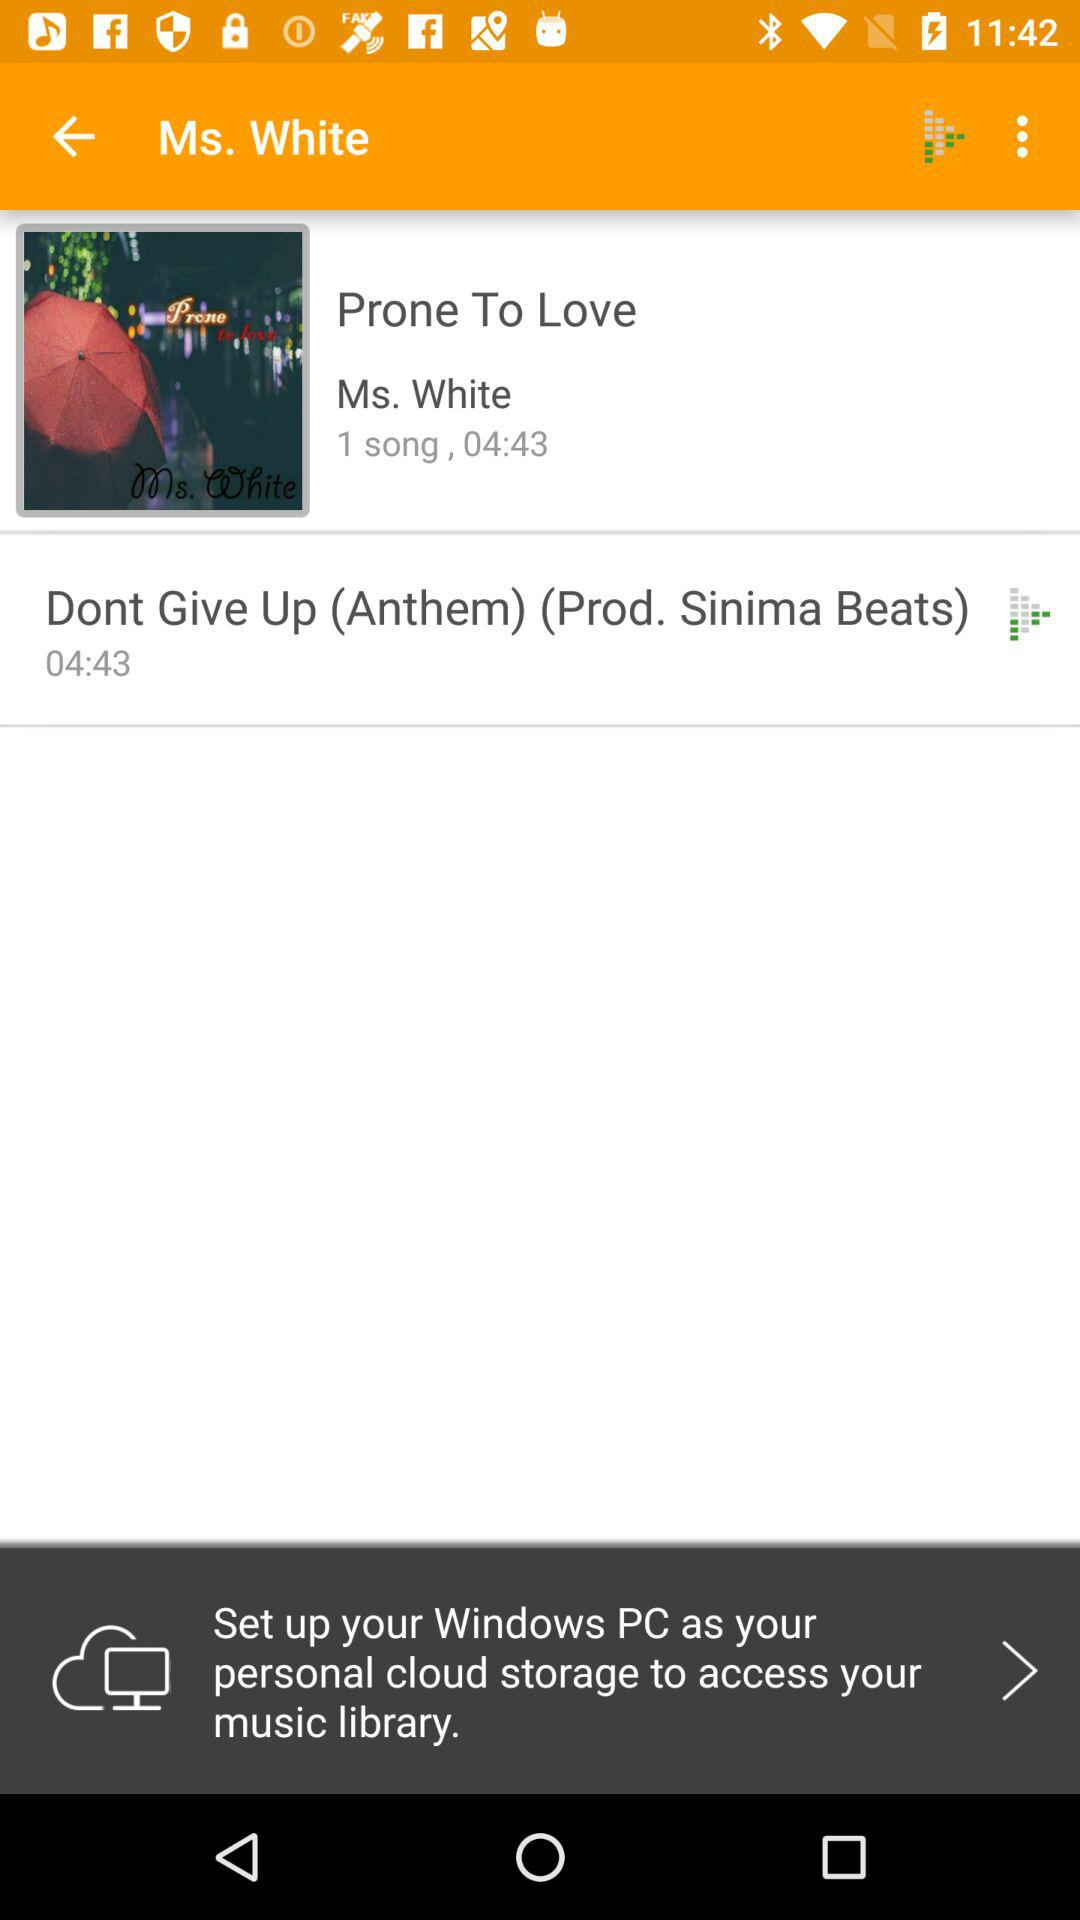How long is the second song?
Answer the question using a single word or phrase. 04:43 